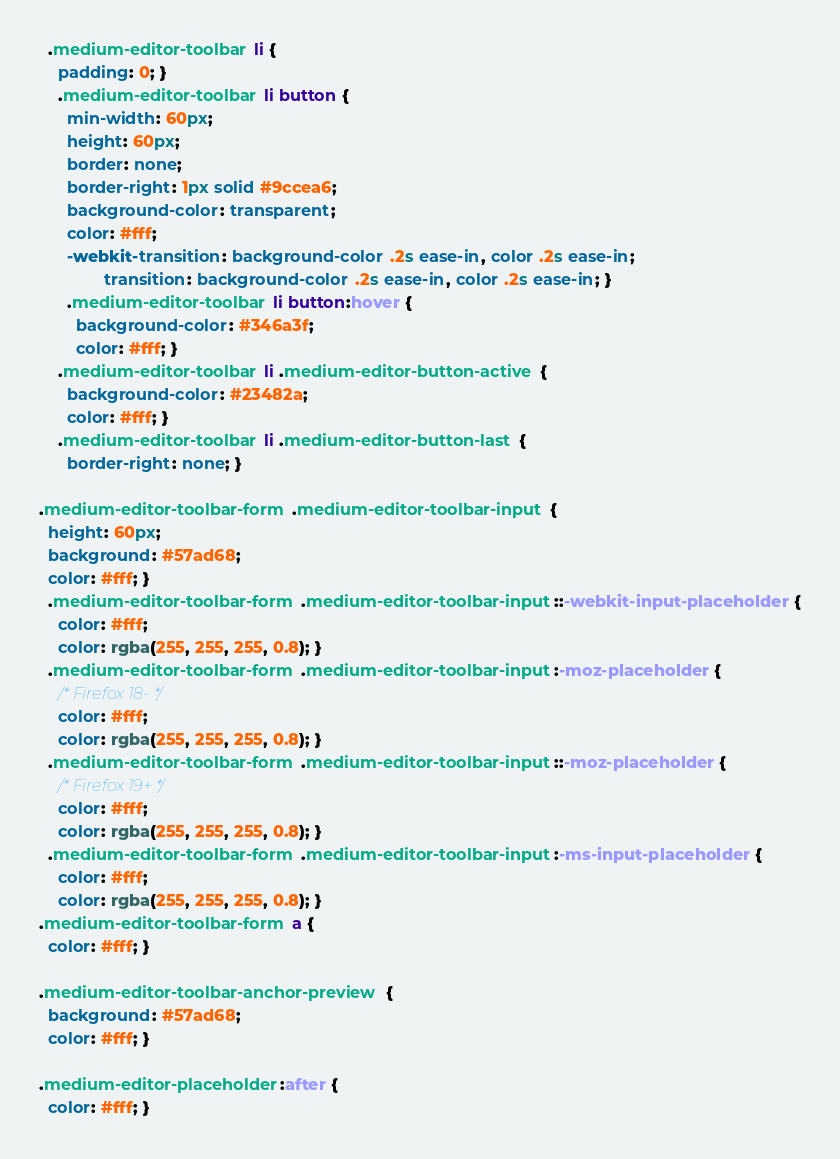<code> <loc_0><loc_0><loc_500><loc_500><_CSS_>  .medium-editor-toolbar li {
    padding: 0; }
    .medium-editor-toolbar li button {
      min-width: 60px;
      height: 60px;
      border: none;
      border-right: 1px solid #9ccea6;
      background-color: transparent;
      color: #fff;
      -webkit-transition: background-color .2s ease-in, color .2s ease-in;
              transition: background-color .2s ease-in, color .2s ease-in; }
      .medium-editor-toolbar li button:hover {
        background-color: #346a3f;
        color: #fff; }
    .medium-editor-toolbar li .medium-editor-button-active {
      background-color: #23482a;
      color: #fff; }
    .medium-editor-toolbar li .medium-editor-button-last {
      border-right: none; }

.medium-editor-toolbar-form .medium-editor-toolbar-input {
  height: 60px;
  background: #57ad68;
  color: #fff; }
  .medium-editor-toolbar-form .medium-editor-toolbar-input::-webkit-input-placeholder {
    color: #fff;
    color: rgba(255, 255, 255, 0.8); }
  .medium-editor-toolbar-form .medium-editor-toolbar-input:-moz-placeholder {
    /* Firefox 18- */
    color: #fff;
    color: rgba(255, 255, 255, 0.8); }
  .medium-editor-toolbar-form .medium-editor-toolbar-input::-moz-placeholder {
    /* Firefox 19+ */
    color: #fff;
    color: rgba(255, 255, 255, 0.8); }
  .medium-editor-toolbar-form .medium-editor-toolbar-input:-ms-input-placeholder {
    color: #fff;
    color: rgba(255, 255, 255, 0.8); }
.medium-editor-toolbar-form a {
  color: #fff; }

.medium-editor-toolbar-anchor-preview {
  background: #57ad68;
  color: #fff; }

.medium-editor-placeholder:after {
  color: #fff; }
</code> 